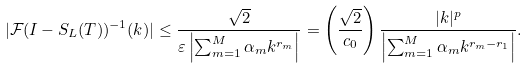<formula> <loc_0><loc_0><loc_500><loc_500>| \mathcal { F } ( I - S _ { L } ( T ) ) ^ { - 1 } ( k ) | \leq \frac { \sqrt { 2 } } { \varepsilon \left | \sum _ { m = 1 } ^ { M } \alpha _ { m } k ^ { r _ { m } } \right | } = \left ( \frac { \sqrt { 2 } } { c _ { 0 } } \right ) \frac { | k | ^ { p } } { \left | \sum _ { m = 1 } ^ { M } \alpha _ { m } k ^ { r _ { m } - r _ { 1 } } \right | } .</formula> 